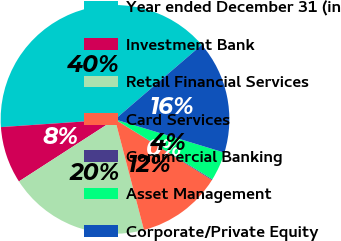Convert chart. <chart><loc_0><loc_0><loc_500><loc_500><pie_chart><fcel>Year ended December 31 (in<fcel>Investment Bank<fcel>Retail Financial Services<fcel>Card Services<fcel>Commercial Banking<fcel>Asset Management<fcel>Corporate/Private Equity<nl><fcel>39.79%<fcel>8.05%<fcel>19.95%<fcel>12.02%<fcel>0.12%<fcel>4.09%<fcel>15.99%<nl></chart> 